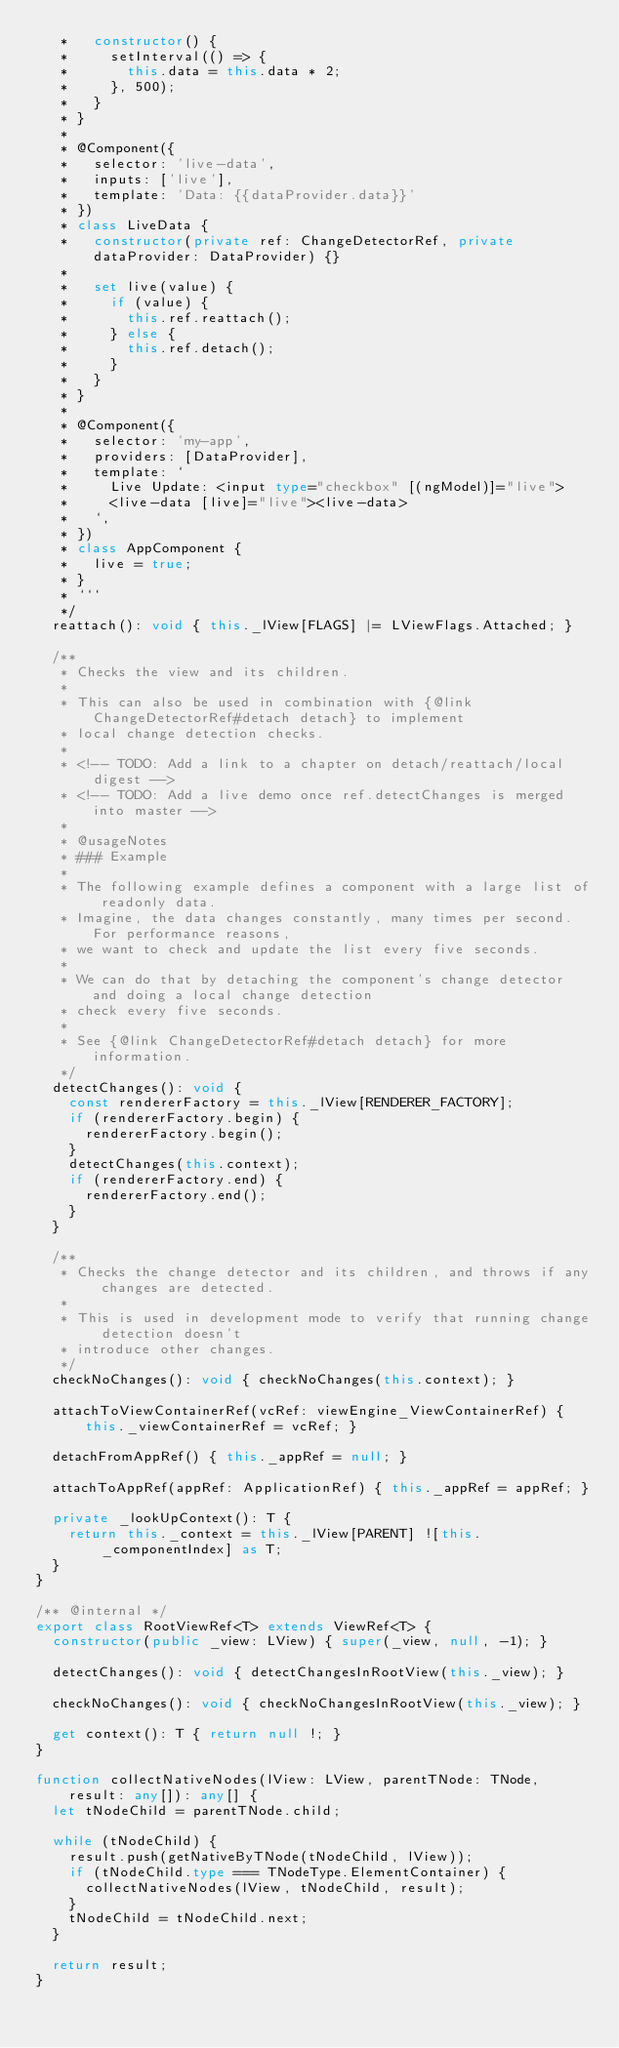Convert code to text. <code><loc_0><loc_0><loc_500><loc_500><_TypeScript_>   *   constructor() {
   *     setInterval(() => {
   *       this.data = this.data * 2;
   *     }, 500);
   *   }
   * }
   *
   * @Component({
   *   selector: 'live-data',
   *   inputs: ['live'],
   *   template: 'Data: {{dataProvider.data}}'
   * })
   * class LiveData {
   *   constructor(private ref: ChangeDetectorRef, private dataProvider: DataProvider) {}
   *
   *   set live(value) {
   *     if (value) {
   *       this.ref.reattach();
   *     } else {
   *       this.ref.detach();
   *     }
   *   }
   * }
   *
   * @Component({
   *   selector: 'my-app',
   *   providers: [DataProvider],
   *   template: `
   *     Live Update: <input type="checkbox" [(ngModel)]="live">
   *     <live-data [live]="live"><live-data>
   *   `,
   * })
   * class AppComponent {
   *   live = true;
   * }
   * ```
   */
  reattach(): void { this._lView[FLAGS] |= LViewFlags.Attached; }

  /**
   * Checks the view and its children.
   *
   * This can also be used in combination with {@link ChangeDetectorRef#detach detach} to implement
   * local change detection checks.
   *
   * <!-- TODO: Add a link to a chapter on detach/reattach/local digest -->
   * <!-- TODO: Add a live demo once ref.detectChanges is merged into master -->
   *
   * @usageNotes
   * ### Example
   *
   * The following example defines a component with a large list of readonly data.
   * Imagine, the data changes constantly, many times per second. For performance reasons,
   * we want to check and update the list every five seconds.
   *
   * We can do that by detaching the component's change detector and doing a local change detection
   * check every five seconds.
   *
   * See {@link ChangeDetectorRef#detach detach} for more information.
   */
  detectChanges(): void {
    const rendererFactory = this._lView[RENDERER_FACTORY];
    if (rendererFactory.begin) {
      rendererFactory.begin();
    }
    detectChanges(this.context);
    if (rendererFactory.end) {
      rendererFactory.end();
    }
  }

  /**
   * Checks the change detector and its children, and throws if any changes are detected.
   *
   * This is used in development mode to verify that running change detection doesn't
   * introduce other changes.
   */
  checkNoChanges(): void { checkNoChanges(this.context); }

  attachToViewContainerRef(vcRef: viewEngine_ViewContainerRef) { this._viewContainerRef = vcRef; }

  detachFromAppRef() { this._appRef = null; }

  attachToAppRef(appRef: ApplicationRef) { this._appRef = appRef; }

  private _lookUpContext(): T {
    return this._context = this._lView[PARENT] ![this._componentIndex] as T;
  }
}

/** @internal */
export class RootViewRef<T> extends ViewRef<T> {
  constructor(public _view: LView) { super(_view, null, -1); }

  detectChanges(): void { detectChangesInRootView(this._view); }

  checkNoChanges(): void { checkNoChangesInRootView(this._view); }

  get context(): T { return null !; }
}

function collectNativeNodes(lView: LView, parentTNode: TNode, result: any[]): any[] {
  let tNodeChild = parentTNode.child;

  while (tNodeChild) {
    result.push(getNativeByTNode(tNodeChild, lView));
    if (tNodeChild.type === TNodeType.ElementContainer) {
      collectNativeNodes(lView, tNodeChild, result);
    }
    tNodeChild = tNodeChild.next;
  }

  return result;
}
</code> 